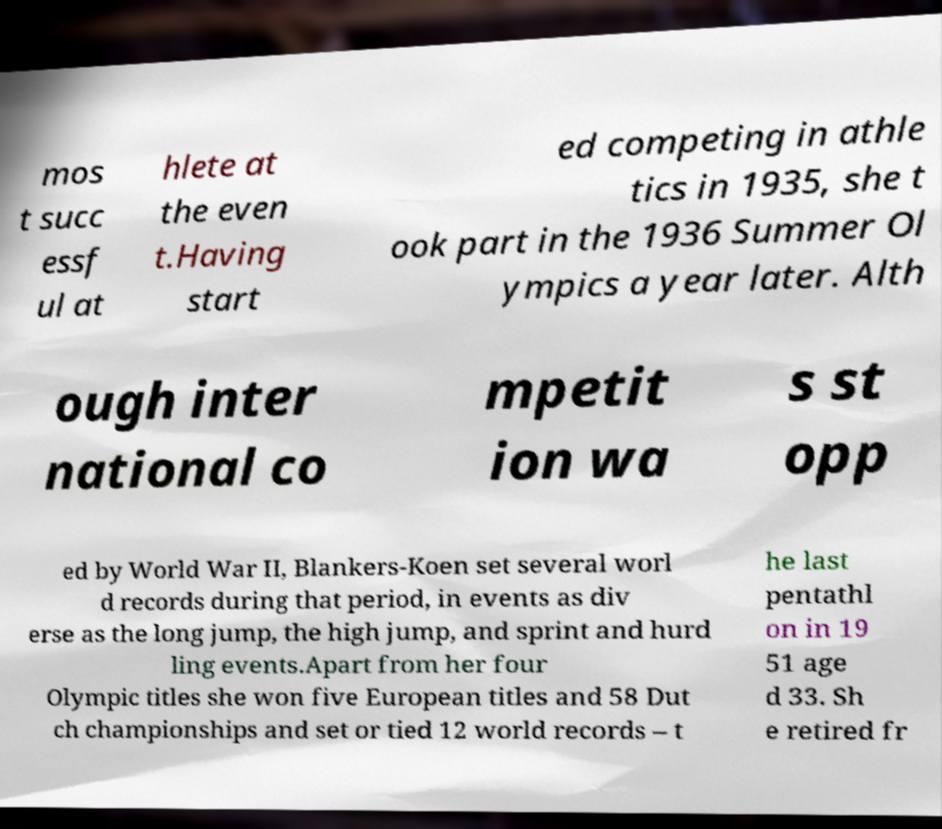For documentation purposes, I need the text within this image transcribed. Could you provide that? mos t succ essf ul at hlete at the even t.Having start ed competing in athle tics in 1935, she t ook part in the 1936 Summer Ol ympics a year later. Alth ough inter national co mpetit ion wa s st opp ed by World War II, Blankers-Koen set several worl d records during that period, in events as div erse as the long jump, the high jump, and sprint and hurd ling events.Apart from her four Olympic titles she won five European titles and 58 Dut ch championships and set or tied 12 world records – t he last pentathl on in 19 51 age d 33. Sh e retired fr 